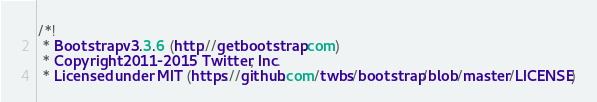<code> <loc_0><loc_0><loc_500><loc_500><_CSS_>/*!
 * Bootstrap v3.3.6 (http://getbootstrap.com)
 * Copyright 2011-2015 Twitter, Inc.
 * Licensed under MIT (https://github.com/twbs/bootstrap/blob/master/LICENSE)</code> 